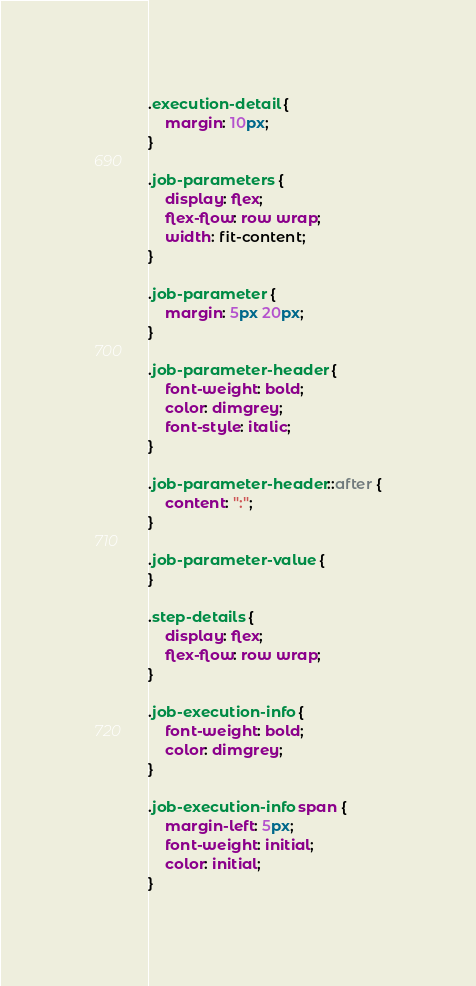<code> <loc_0><loc_0><loc_500><loc_500><_CSS_>.execution-detail {
    margin: 10px;
}

.job-parameters {
    display: flex;
    flex-flow: row wrap;
    width: fit-content;
}

.job-parameter {
    margin: 5px 20px;
}

.job-parameter-header {
    font-weight: bold;
    color: dimgrey;
    font-style: italic;
}

.job-parameter-header::after {
    content: ":";
}

.job-parameter-value {
}

.step-details {
    display: flex;
    flex-flow: row wrap;
}

.job-execution-info {
    font-weight: bold;
    color: dimgrey;
}

.job-execution-info span {
    margin-left: 5px;
    font-weight: initial;
    color: initial;
}</code> 